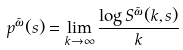Convert formula to latex. <formula><loc_0><loc_0><loc_500><loc_500>p ^ { \tilde { \omega } } ( s ) = \lim _ { k \to \infty } \frac { \log S ^ { \tilde { \omega } } ( k , s ) } k</formula> 